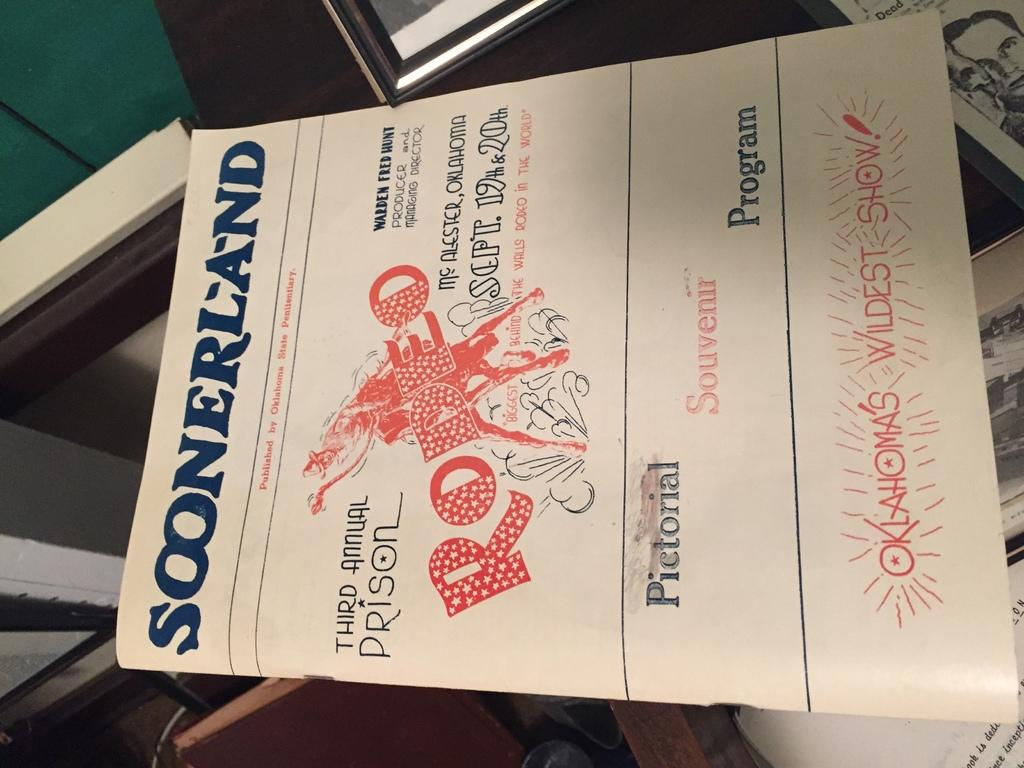<image>
Relay a brief, clear account of the picture shown. A musical program with the name Soonerland printed at the top. 